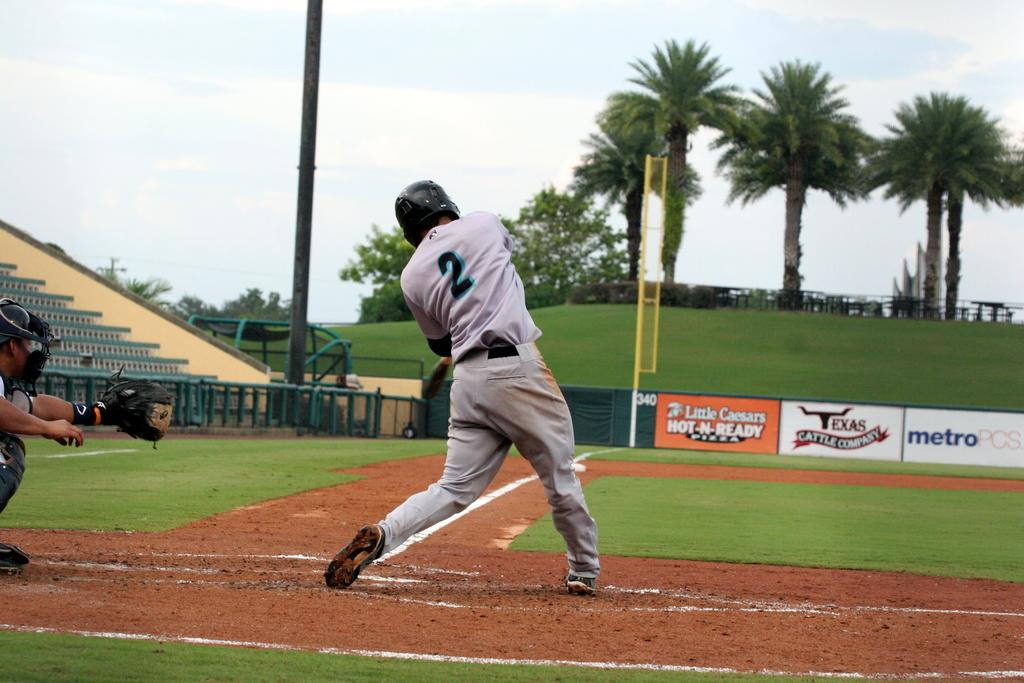<image>
Present a compact description of the photo's key features. A man in a baseball uniform with the number two on is back is swinging his bat. 